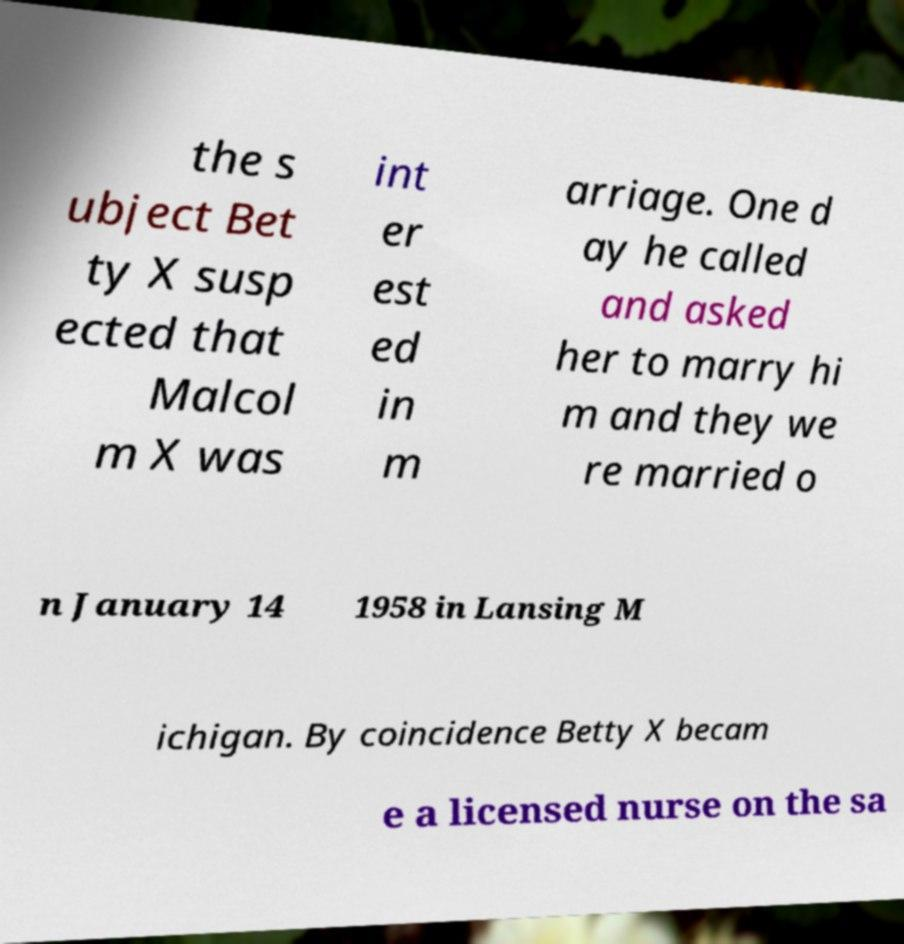Can you accurately transcribe the text from the provided image for me? the s ubject Bet ty X susp ected that Malcol m X was int er est ed in m arriage. One d ay he called and asked her to marry hi m and they we re married o n January 14 1958 in Lansing M ichigan. By coincidence Betty X becam e a licensed nurse on the sa 